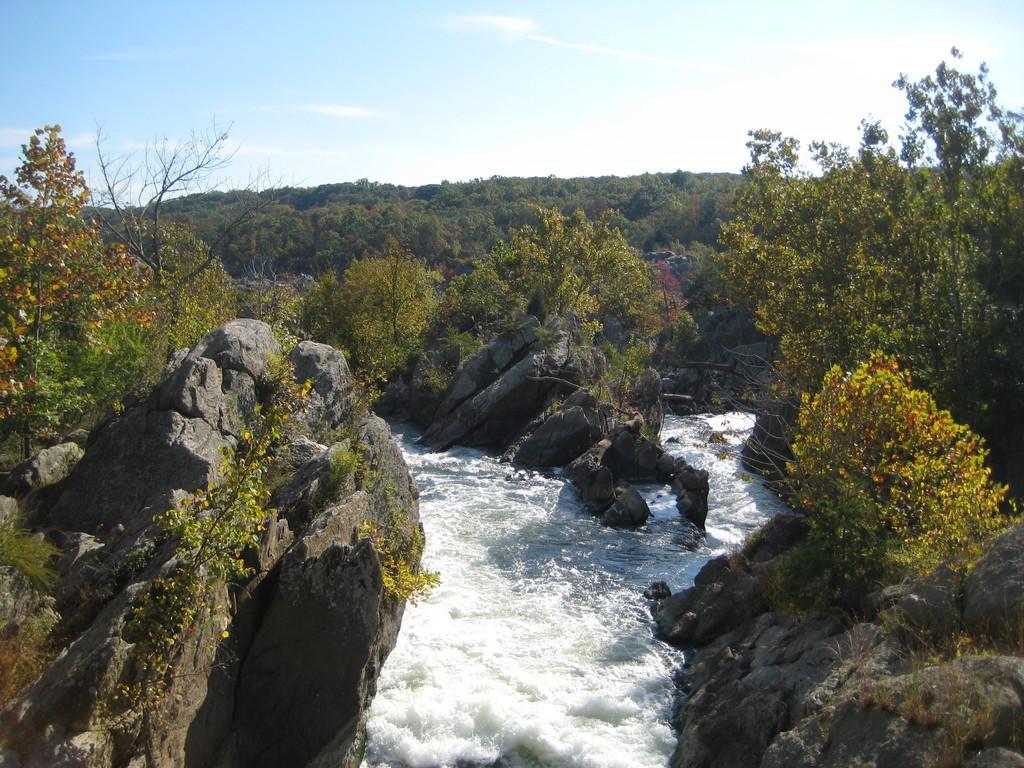In one or two sentences, can you explain what this image depicts? In this picture we can see water lake, around we can see some rocks and trees. 